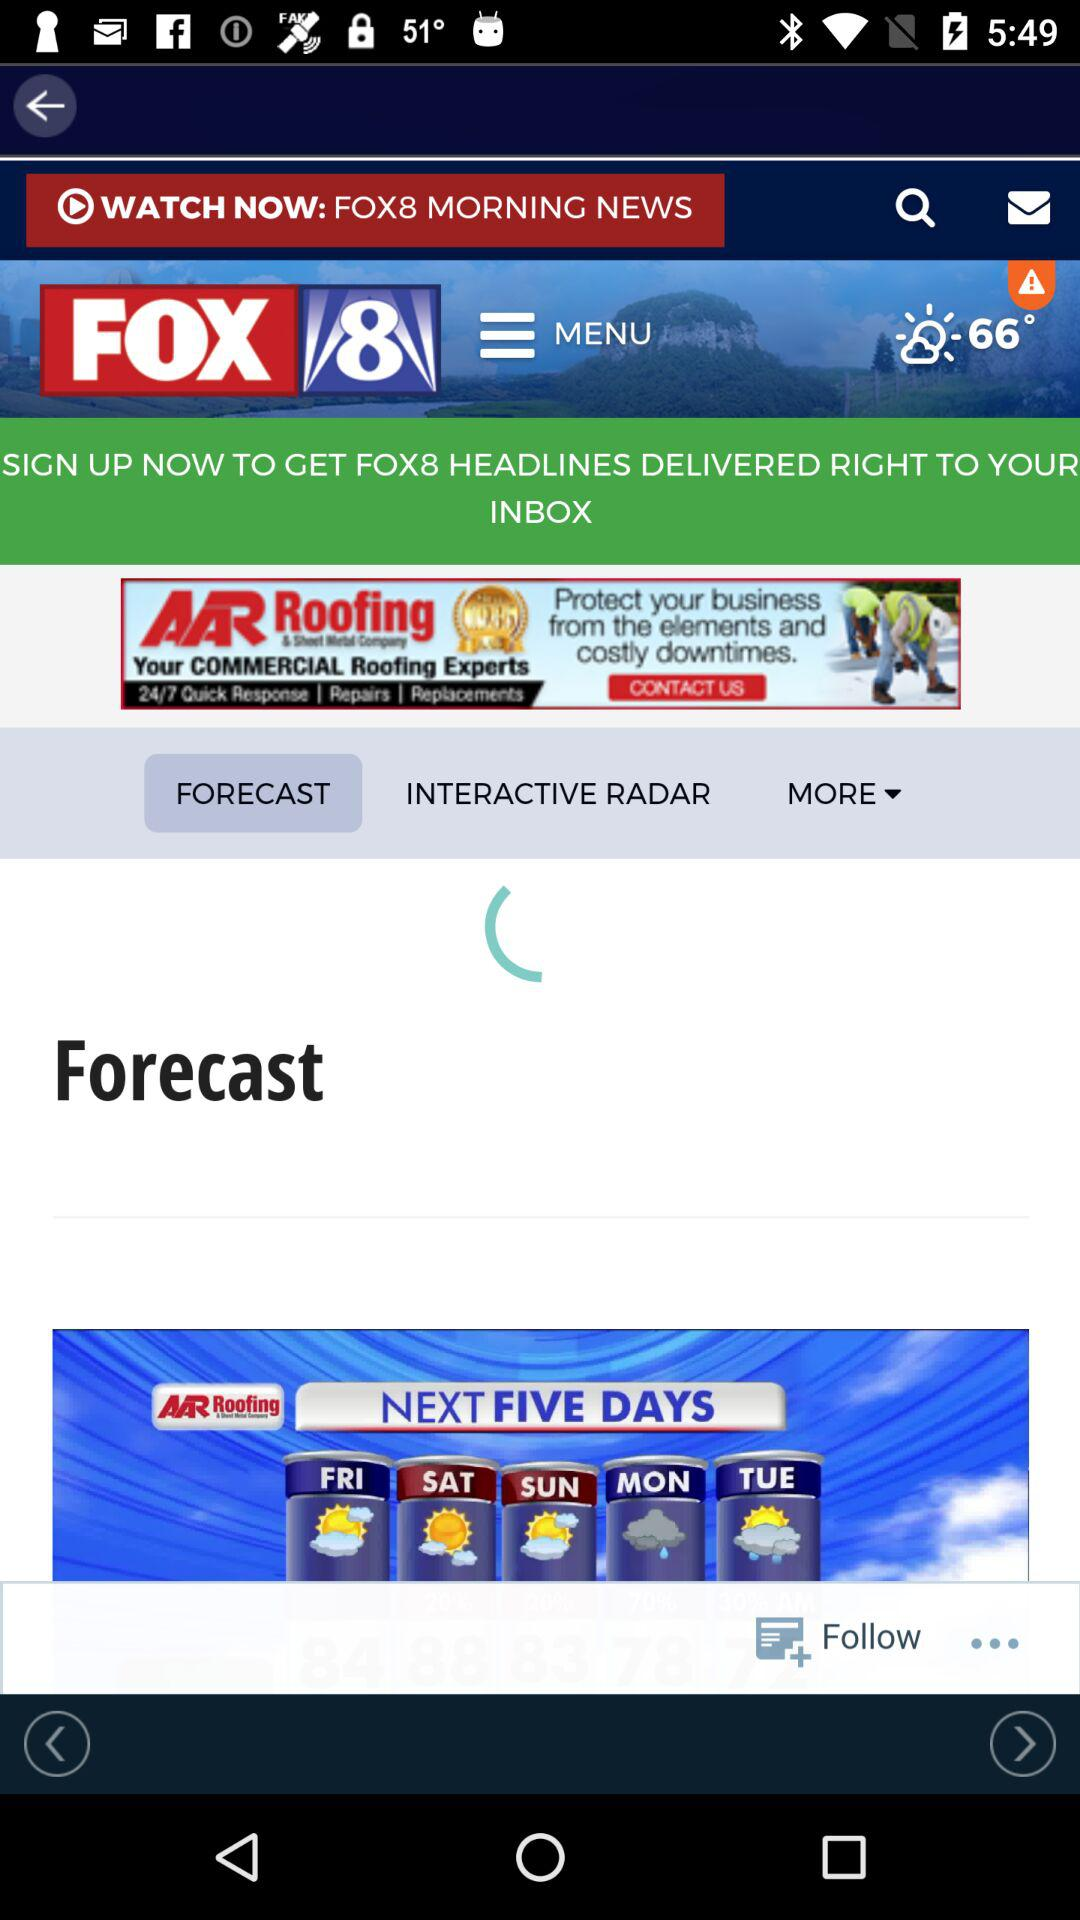Which tab is selected? The selected tab is "FORECAST". 